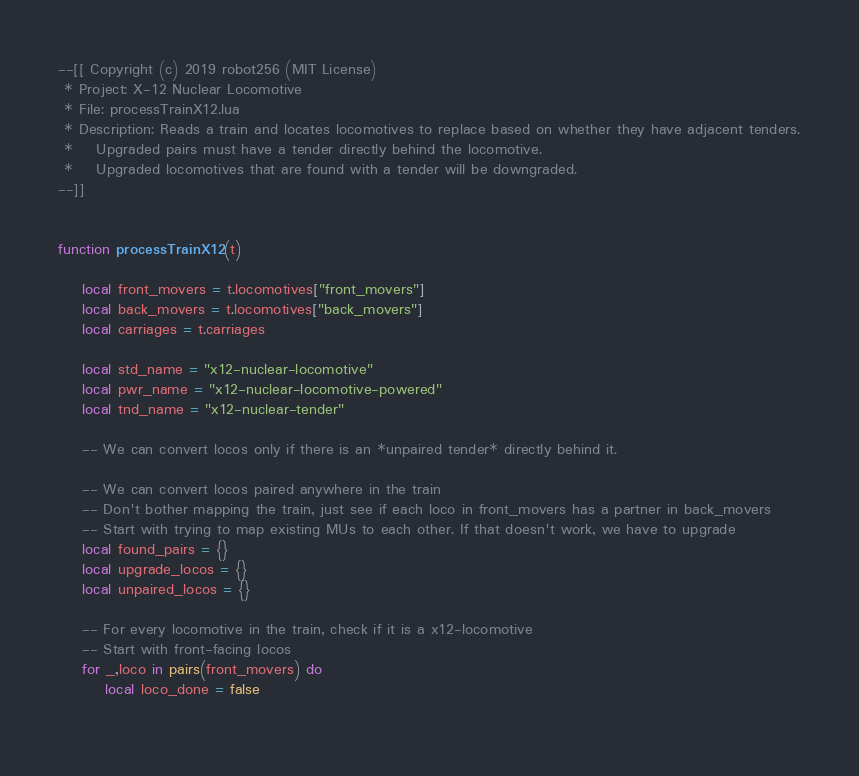<code> <loc_0><loc_0><loc_500><loc_500><_Lua_>--[[ Copyright (c) 2019 robot256 (MIT License)
 * Project: X-12 Nuclear Locomotive
 * File: processTrainX12.lua
 * Description: Reads a train and locates locomotives to replace based on whether they have adjacent tenders.
 *    Upgraded pairs must have a tender directly behind the locomotive.
 *    Upgraded locomotives that are found with a tender will be downgraded.
--]]


function processTrainX12(t)

	local front_movers = t.locomotives["front_movers"]
	local back_movers = t.locomotives["back_movers"]
	local carriages = t.carriages
	
	local std_name = "x12-nuclear-locomotive"
	local pwr_name = "x12-nuclear-locomotive-powered"
	local tnd_name = "x12-nuclear-tender"
	
	-- We can convert locos only if there is an *unpaired tender* directly behind it.
	
	-- We can convert locos paired anywhere in the train
	-- Don't bother mapping the train, just see if each loco in front_movers has a partner in back_movers
	-- Start with trying to map existing MUs to each other. If that doesn't work, we have to upgrade
	local found_pairs = {}
	local upgrade_locos = {}
	local unpaired_locos = {}
	
	-- For every locomotive in the train, check if it is a x12-locomotive
	-- Start with front-facing locos
	for _,loco in pairs(front_movers) do
		local loco_done = false
		</code> 